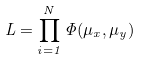<formula> <loc_0><loc_0><loc_500><loc_500>L = \prod _ { i = 1 } ^ { N } \Phi ( \mu _ { x } , \mu _ { y } )</formula> 